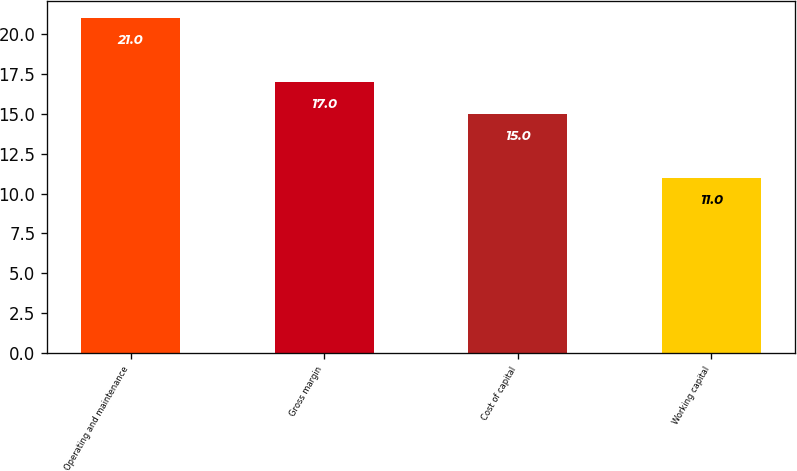Convert chart. <chart><loc_0><loc_0><loc_500><loc_500><bar_chart><fcel>Operating and maintenance<fcel>Gross margin<fcel>Cost of capital<fcel>Working capital<nl><fcel>21<fcel>17<fcel>15<fcel>11<nl></chart> 